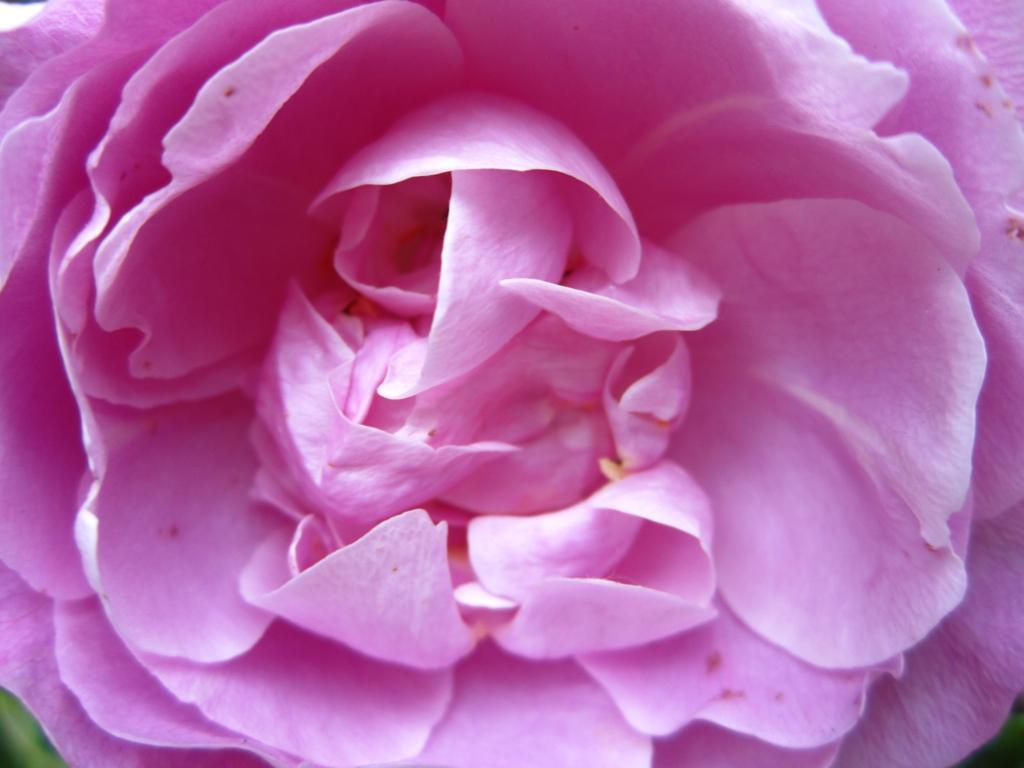What is the main subject of the image? The main subject of the image is a flower. Can you describe the flower in the image? The image is a zoomed-in picture of a flower, so it focuses on the details of the flower. What type of string can be seen connecting the flower to a railway in the image? There is no string or railway present in the image; it is a close-up picture of a flower. 